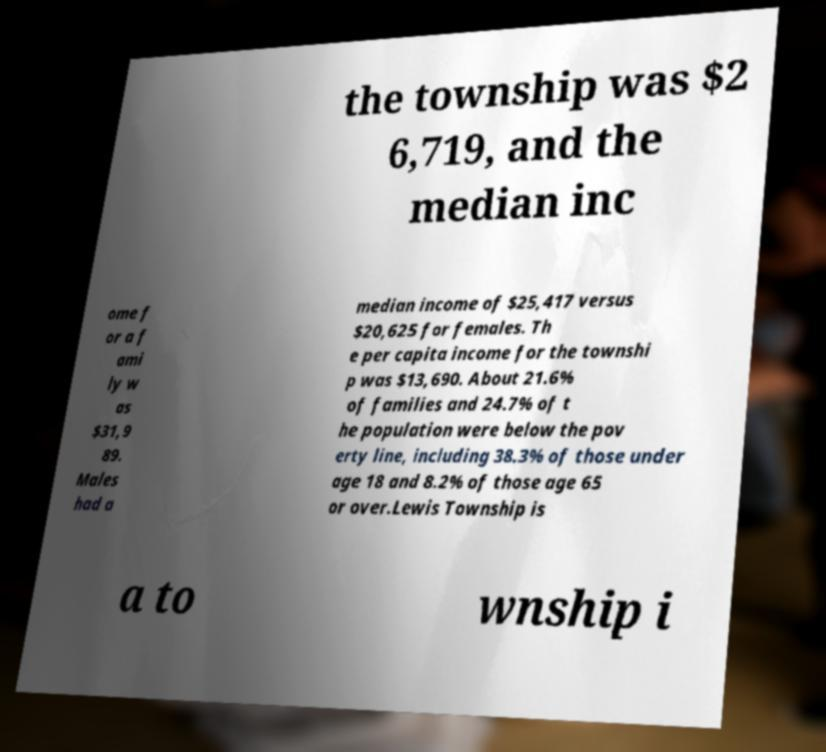There's text embedded in this image that I need extracted. Can you transcribe it verbatim? the township was $2 6,719, and the median inc ome f or a f ami ly w as $31,9 89. Males had a median income of $25,417 versus $20,625 for females. Th e per capita income for the townshi p was $13,690. About 21.6% of families and 24.7% of t he population were below the pov erty line, including 38.3% of those under age 18 and 8.2% of those age 65 or over.Lewis Township is a to wnship i 